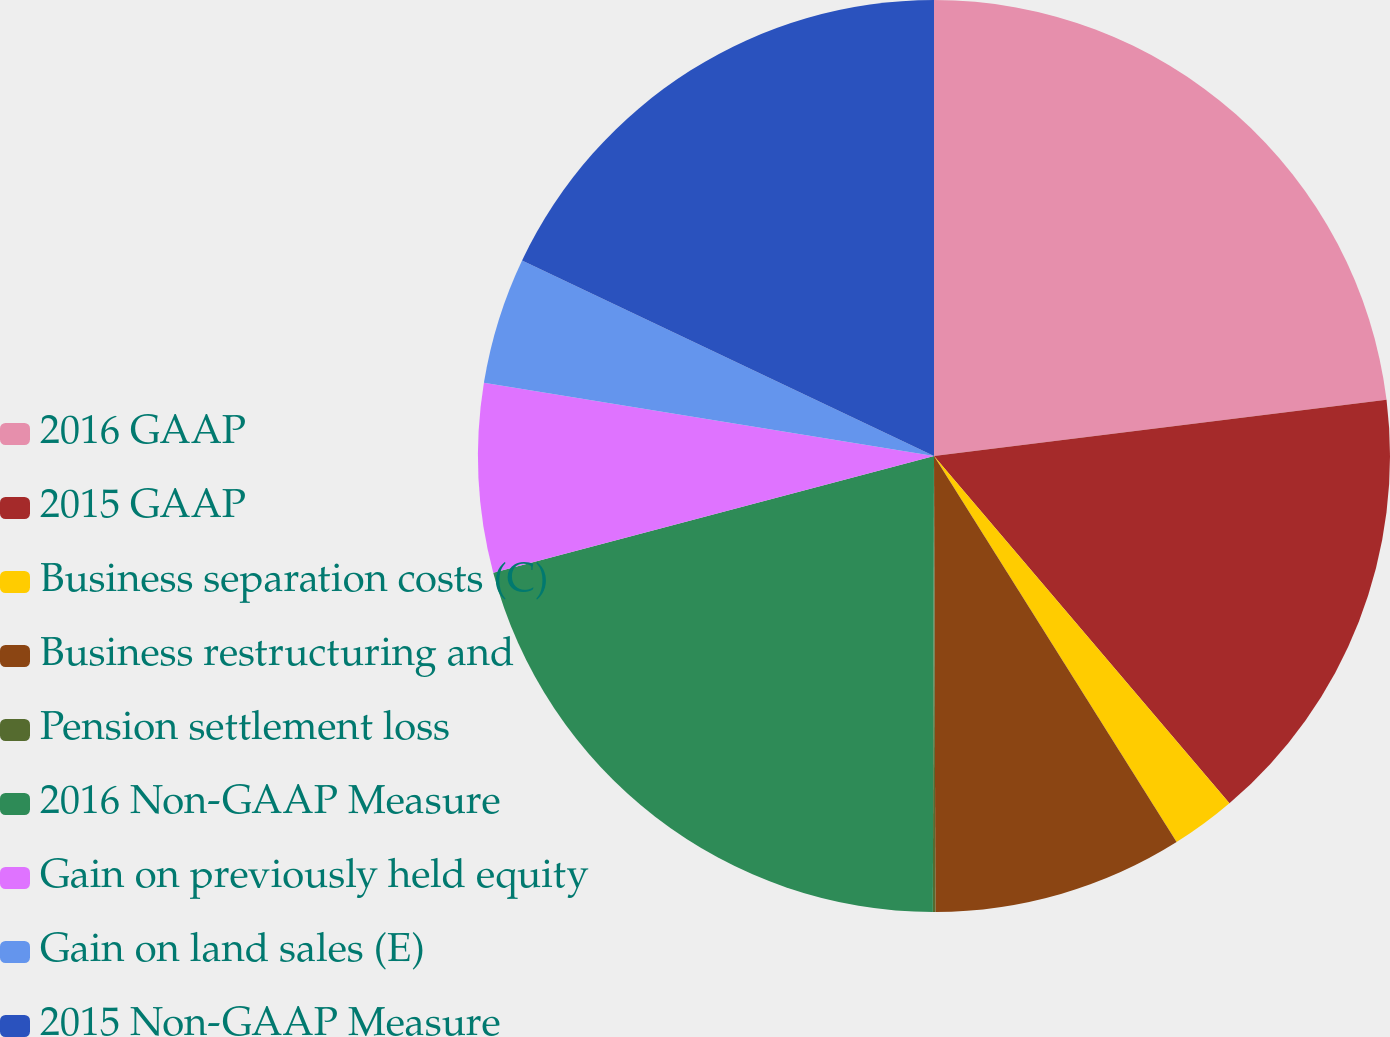Convert chart to OTSL. <chart><loc_0><loc_0><loc_500><loc_500><pie_chart><fcel>2016 GAAP<fcel>2015 GAAP<fcel>Business separation costs (C)<fcel>Business restructuring and<fcel>Pension settlement loss<fcel>2016 Non-GAAP Measure<fcel>Gain on previously held equity<fcel>Gain on land sales (E)<fcel>2015 Non-GAAP Measure<nl><fcel>23.04%<fcel>15.75%<fcel>2.29%<fcel>8.88%<fcel>0.09%<fcel>20.84%<fcel>6.69%<fcel>4.49%<fcel>17.95%<nl></chart> 